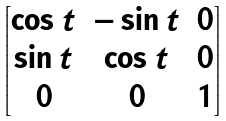Convert formula to latex. <formula><loc_0><loc_0><loc_500><loc_500>\begin{bmatrix} \cos t & - \sin t & 0 \\ \sin t & \cos t & 0 \\ 0 & 0 & 1 \end{bmatrix}</formula> 